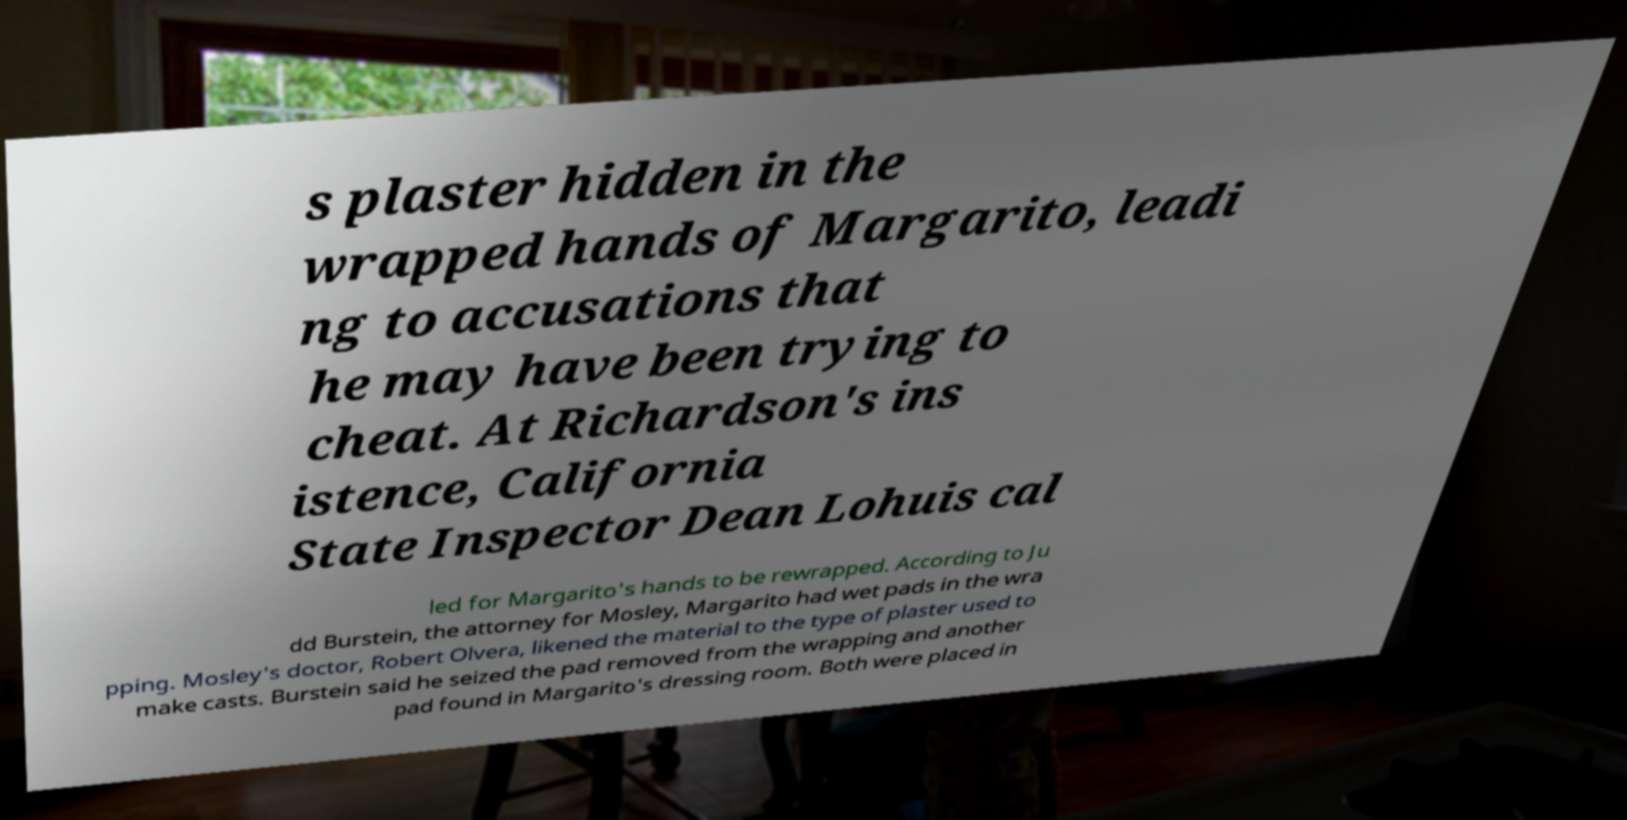What messages or text are displayed in this image? I need them in a readable, typed format. s plaster hidden in the wrapped hands of Margarito, leadi ng to accusations that he may have been trying to cheat. At Richardson's ins istence, California State Inspector Dean Lohuis cal led for Margarito's hands to be rewrapped. According to Ju dd Burstein, the attorney for Mosley, Margarito had wet pads in the wra pping. Mosley's doctor, Robert Olvera, likened the material to the type of plaster used to make casts. Burstein said he seized the pad removed from the wrapping and another pad found in Margarito's dressing room. Both were placed in 